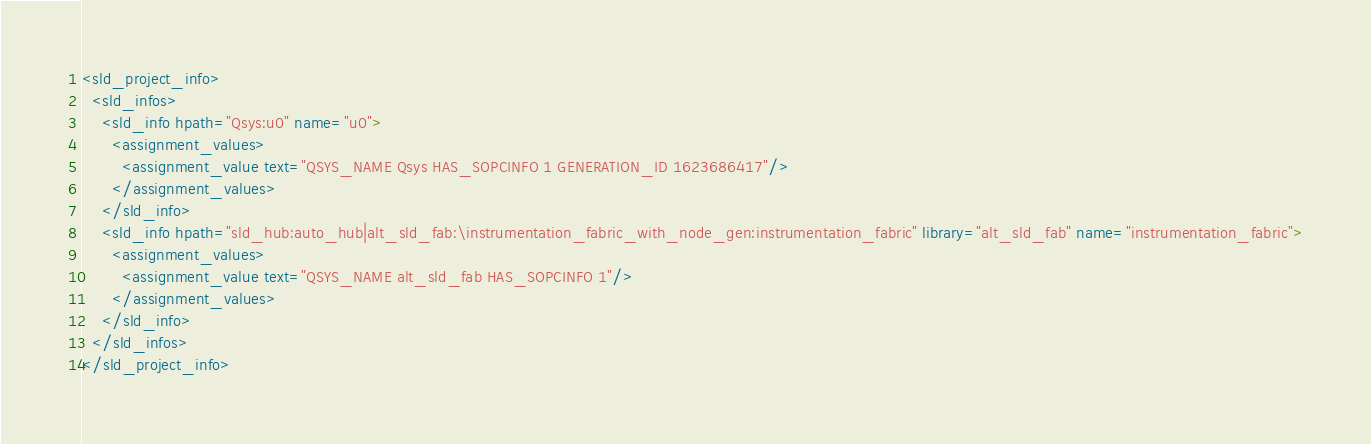Convert code to text. <code><loc_0><loc_0><loc_500><loc_500><_Scheme_><sld_project_info>
  <sld_infos>
    <sld_info hpath="Qsys:u0" name="u0">
      <assignment_values>
        <assignment_value text="QSYS_NAME Qsys HAS_SOPCINFO 1 GENERATION_ID 1623686417"/>
      </assignment_values>
    </sld_info>
    <sld_info hpath="sld_hub:auto_hub|alt_sld_fab:\instrumentation_fabric_with_node_gen:instrumentation_fabric" library="alt_sld_fab" name="instrumentation_fabric">
      <assignment_values>
        <assignment_value text="QSYS_NAME alt_sld_fab HAS_SOPCINFO 1"/>
      </assignment_values>
    </sld_info>
  </sld_infos>
</sld_project_info>
</code> 